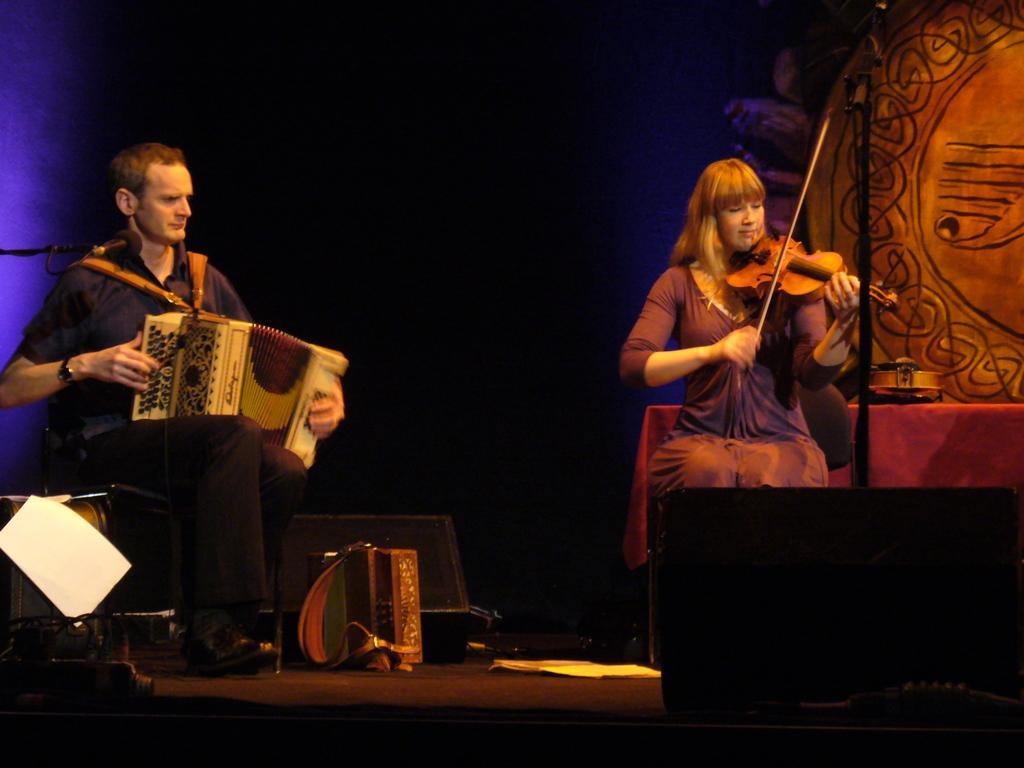Can you describe this image briefly? This picture is of inside. On the right there is a woman sitting on the chair and playing violin. On the left there is a man wearing black color t-shirt, sitting on the chair and playing a musical instrument. In the center there is a box placed on the ground and in the background we can see a table and a wall. 